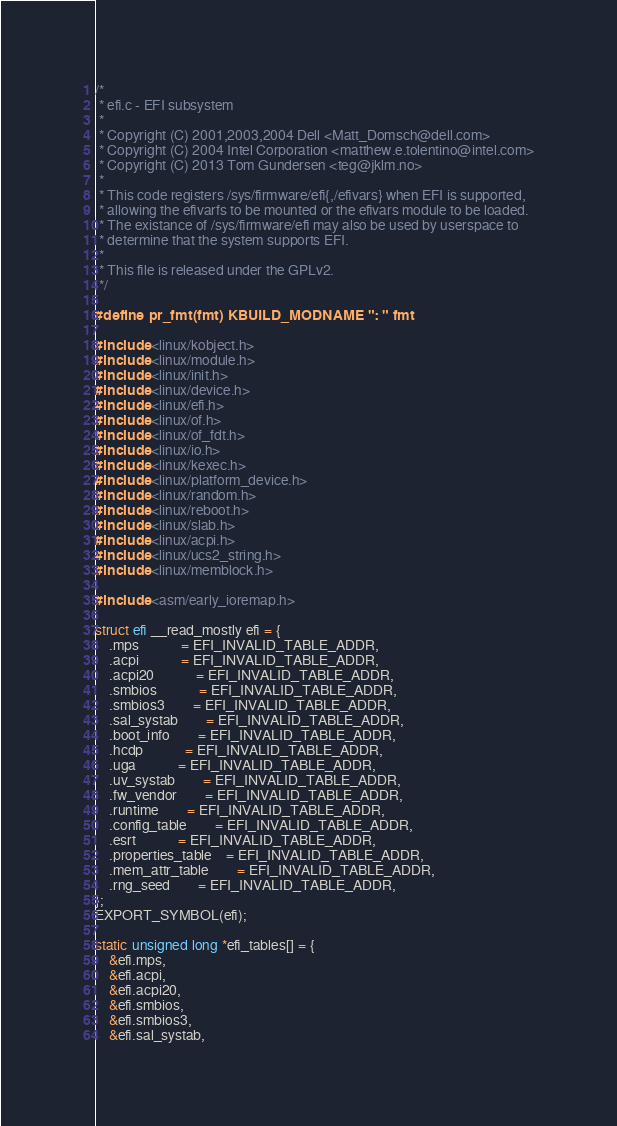Convert code to text. <code><loc_0><loc_0><loc_500><loc_500><_C_>/*
 * efi.c - EFI subsystem
 *
 * Copyright (C) 2001,2003,2004 Dell <Matt_Domsch@dell.com>
 * Copyright (C) 2004 Intel Corporation <matthew.e.tolentino@intel.com>
 * Copyright (C) 2013 Tom Gundersen <teg@jklm.no>
 *
 * This code registers /sys/firmware/efi{,/efivars} when EFI is supported,
 * allowing the efivarfs to be mounted or the efivars module to be loaded.
 * The existance of /sys/firmware/efi may also be used by userspace to
 * determine that the system supports EFI.
 *
 * This file is released under the GPLv2.
 */

#define pr_fmt(fmt) KBUILD_MODNAME ": " fmt

#include <linux/kobject.h>
#include <linux/module.h>
#include <linux/init.h>
#include <linux/device.h>
#include <linux/efi.h>
#include <linux/of.h>
#include <linux/of_fdt.h>
#include <linux/io.h>
#include <linux/kexec.h>
#include <linux/platform_device.h>
#include <linux/random.h>
#include <linux/reboot.h>
#include <linux/slab.h>
#include <linux/acpi.h>
#include <linux/ucs2_string.h>
#include <linux/memblock.h>

#include <asm/early_ioremap.h>

struct efi __read_mostly efi = {
	.mps			= EFI_INVALID_TABLE_ADDR,
	.acpi			= EFI_INVALID_TABLE_ADDR,
	.acpi20			= EFI_INVALID_TABLE_ADDR,
	.smbios			= EFI_INVALID_TABLE_ADDR,
	.smbios3		= EFI_INVALID_TABLE_ADDR,
	.sal_systab		= EFI_INVALID_TABLE_ADDR,
	.boot_info		= EFI_INVALID_TABLE_ADDR,
	.hcdp			= EFI_INVALID_TABLE_ADDR,
	.uga			= EFI_INVALID_TABLE_ADDR,
	.uv_systab		= EFI_INVALID_TABLE_ADDR,
	.fw_vendor		= EFI_INVALID_TABLE_ADDR,
	.runtime		= EFI_INVALID_TABLE_ADDR,
	.config_table		= EFI_INVALID_TABLE_ADDR,
	.esrt			= EFI_INVALID_TABLE_ADDR,
	.properties_table	= EFI_INVALID_TABLE_ADDR,
	.mem_attr_table		= EFI_INVALID_TABLE_ADDR,
	.rng_seed		= EFI_INVALID_TABLE_ADDR,
};
EXPORT_SYMBOL(efi);

static unsigned long *efi_tables[] = {
	&efi.mps,
	&efi.acpi,
	&efi.acpi20,
	&efi.smbios,
	&efi.smbios3,
	&efi.sal_systab,</code> 